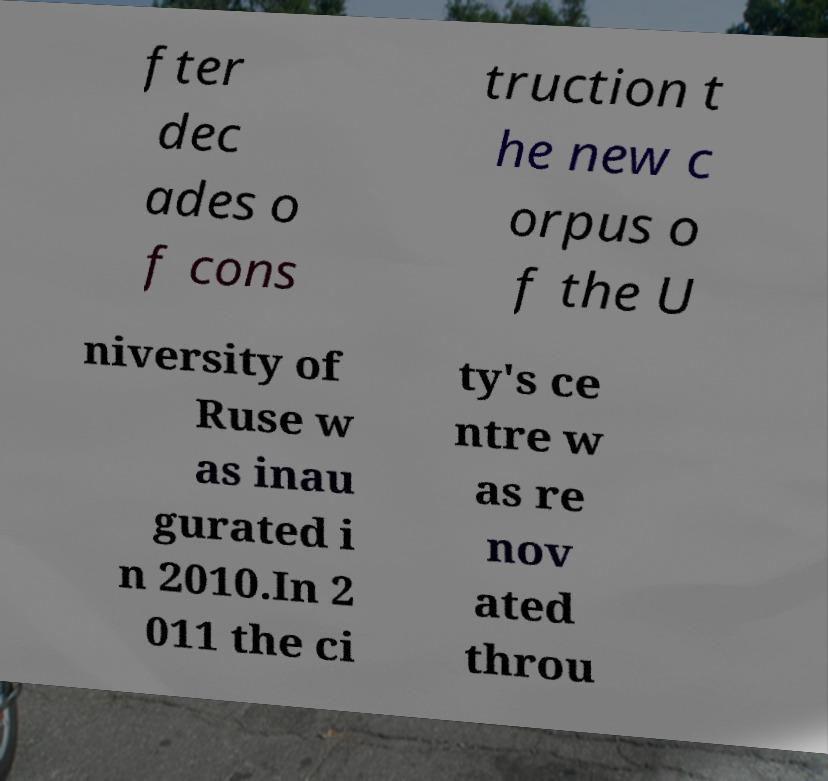For documentation purposes, I need the text within this image transcribed. Could you provide that? fter dec ades o f cons truction t he new c orpus o f the U niversity of Ruse w as inau gurated i n 2010.In 2 011 the ci ty's ce ntre w as re nov ated throu 